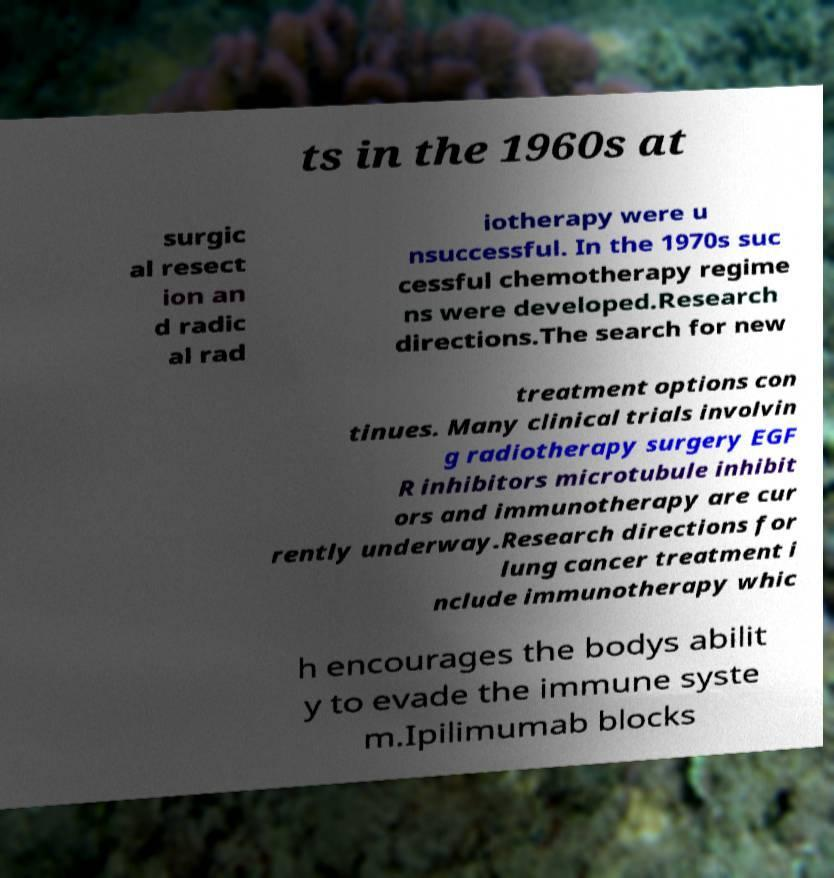Can you read and provide the text displayed in the image?This photo seems to have some interesting text. Can you extract and type it out for me? ts in the 1960s at surgic al resect ion an d radic al rad iotherapy were u nsuccessful. In the 1970s suc cessful chemotherapy regime ns were developed.Research directions.The search for new treatment options con tinues. Many clinical trials involvin g radiotherapy surgery EGF R inhibitors microtubule inhibit ors and immunotherapy are cur rently underway.Research directions for lung cancer treatment i nclude immunotherapy whic h encourages the bodys abilit y to evade the immune syste m.Ipilimumab blocks 